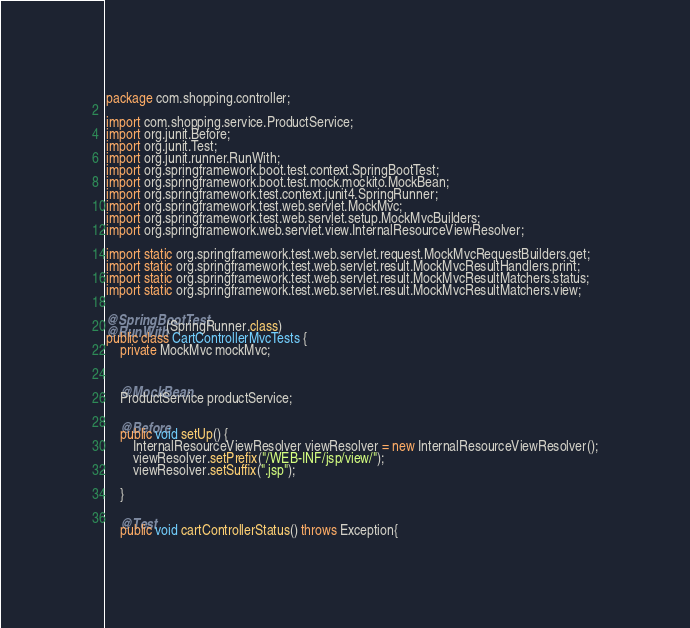Convert code to text. <code><loc_0><loc_0><loc_500><loc_500><_Java_>package com.shopping.controller;

import com.shopping.service.ProductService;
import org.junit.Before;
import org.junit.Test;
import org.junit.runner.RunWith;
import org.springframework.boot.test.context.SpringBootTest;
import org.springframework.boot.test.mock.mockito.MockBean;
import org.springframework.test.context.junit4.SpringRunner;
import org.springframework.test.web.servlet.MockMvc;
import org.springframework.test.web.servlet.setup.MockMvcBuilders;
import org.springframework.web.servlet.view.InternalResourceViewResolver;

import static org.springframework.test.web.servlet.request.MockMvcRequestBuilders.get;
import static org.springframework.test.web.servlet.result.MockMvcResultHandlers.print;
import static org.springframework.test.web.servlet.result.MockMvcResultMatchers.status;
import static org.springframework.test.web.servlet.result.MockMvcResultMatchers.view;

@SpringBootTest
@RunWith(SpringRunner.class)
public class CartControllerMvcTests {
    private MockMvc mockMvc;


    @MockBean
    ProductService productService;

    @Before
    public void setUp() {
        InternalResourceViewResolver viewResolver = new InternalResourceViewResolver();
        viewResolver.setPrefix("/WEB-INF/jsp/view/");
        viewResolver.setSuffix(".jsp");

    }

    @Test
    public void cartControllerStatus() throws Exception{</code> 